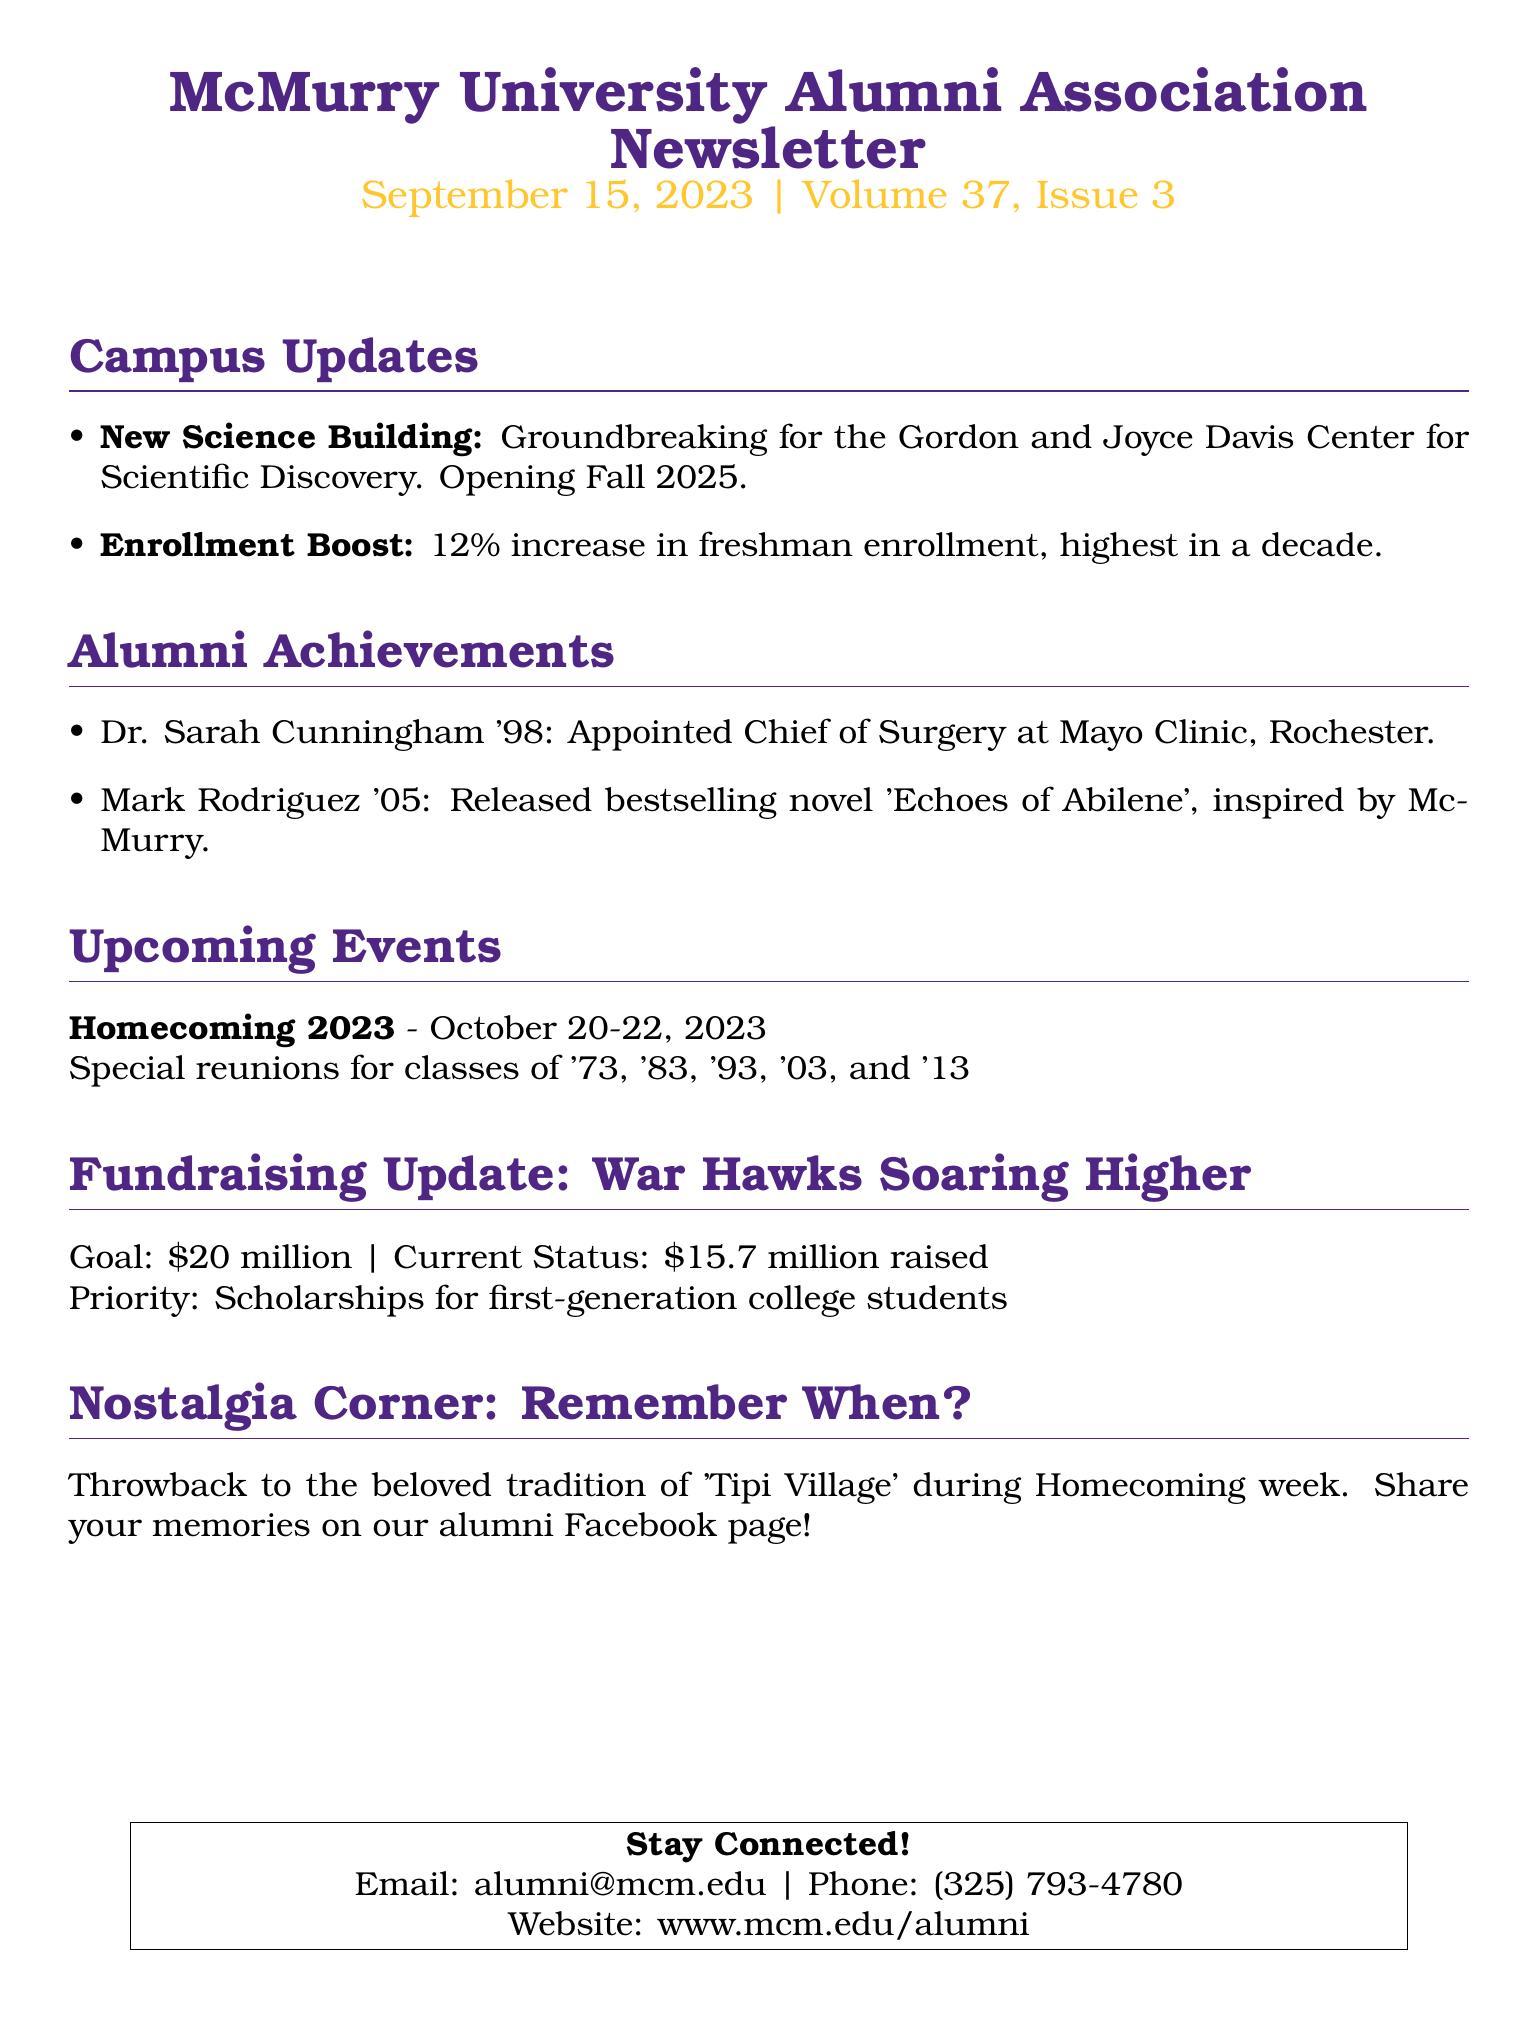What is the date of the newsletter? The date is specified in the header of the newsletter, which reads September 15, 2023.
Answer: September 15, 2023 Who is the Chief of Surgery at Mayo Clinic, Rochester? The document states that Dr. Sarah Cunningham '98 has been appointed to this position.
Answer: Dr. Sarah Cunningham '98 What is the goal amount for the fundraising initiative? The goal amount is mentioned in the Fundraising Update section, which states a goal of 20 million dollars.
Answer: $20 million When will Homecoming 2023 be held? The document specifies the dates for Homecoming 2023, which are October 20-22, 2023.
Answer: October 20-22, 2023 What notable achievement does Mark Rodriguez '05 have? He released a bestselling novel titled 'Echoes of Abilene' that was inspired by McMurry.
Answer: 'Echoes of Abilene' What landmark is set to open in Fall 2025? The document mentions the Gordon and Joyce Davis Center for Scientific Discovery as the new building.
Answer: Gordon and Joyce Davis Center for Scientific Discovery What is the current amount raised in the fundraising update? The document states the current status of funds raised is 15.7 million dollars.
Answer: $15.7 million What tradition is recalled in the Nostalgia Corner? The tradition recalled is 'Tipi Village' during Homecoming week.
Answer: Tipi Village 